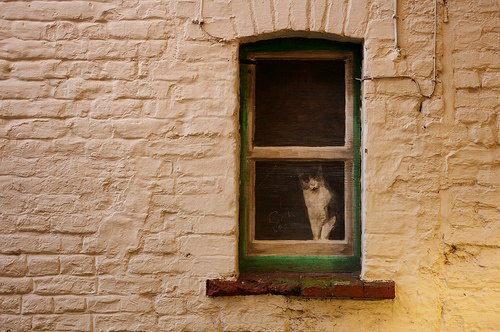Describe the objects in this image and their specific colors. I can see a cat in brown, black, tan, gray, and maroon tones in this image. 